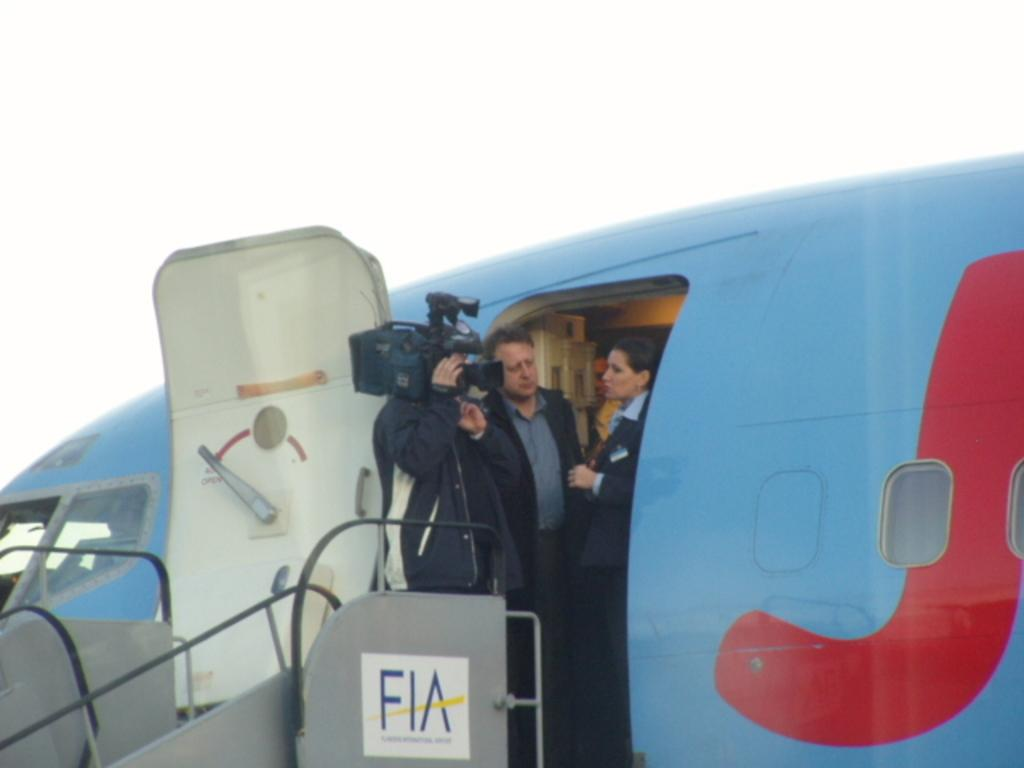<image>
Write a terse but informative summary of the picture. A news interview being filmed with a flight attendant at the entrance of a FIA plane. 